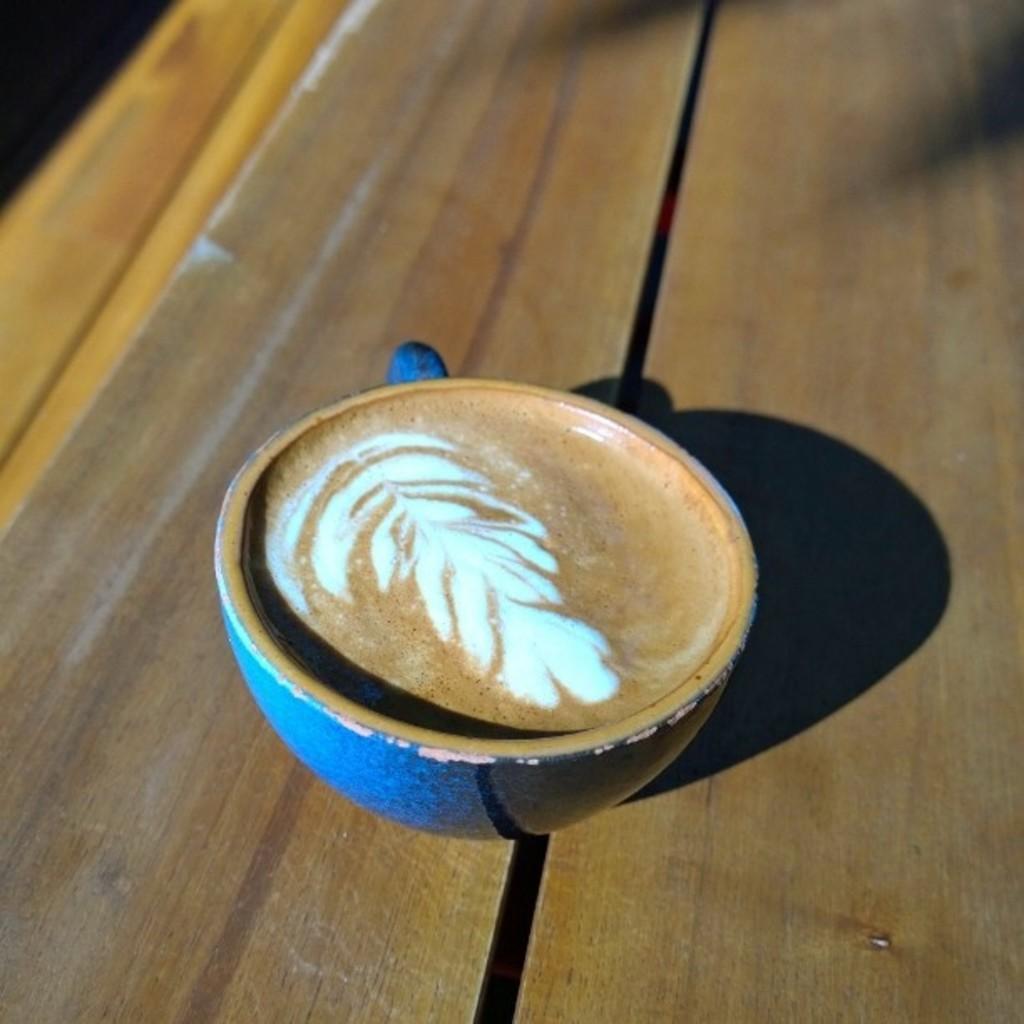Could you give a brief overview of what you see in this image? In the image we can see a wooden surface. On it there is a cup with a liquid in it. 